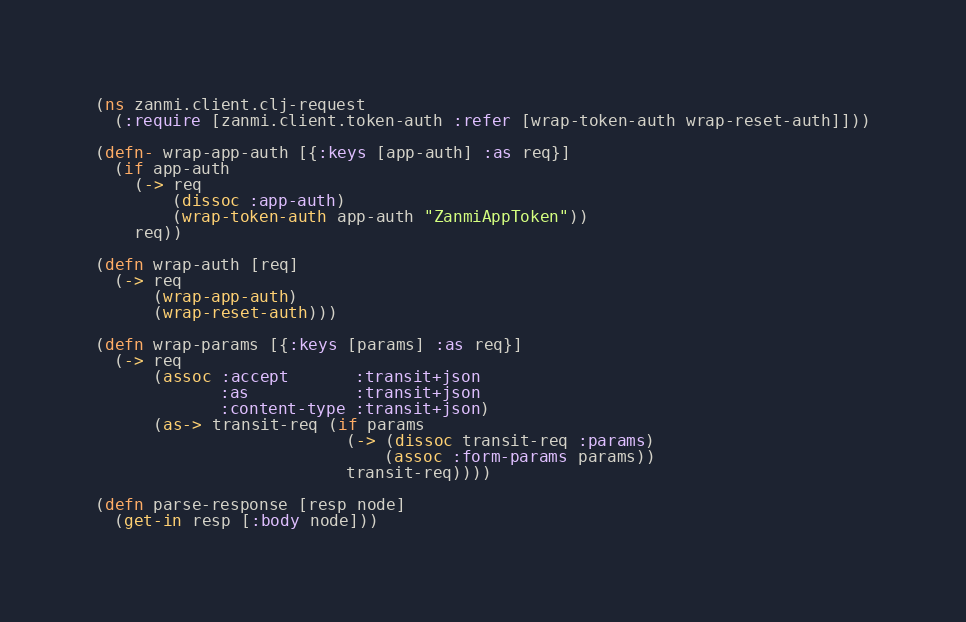Convert code to text. <code><loc_0><loc_0><loc_500><loc_500><_Clojure_>(ns zanmi.client.clj-request
  (:require [zanmi.client.token-auth :refer [wrap-token-auth wrap-reset-auth]]))

(defn- wrap-app-auth [{:keys [app-auth] :as req}]
  (if app-auth
    (-> req
        (dissoc :app-auth)
        (wrap-token-auth app-auth "ZanmiAppToken"))
    req))

(defn wrap-auth [req]
  (-> req
      (wrap-app-auth)
      (wrap-reset-auth)))

(defn wrap-params [{:keys [params] :as req}]
  (-> req
      (assoc :accept       :transit+json
             :as           :transit+json
             :content-type :transit+json)
      (as-> transit-req (if params
                          (-> (dissoc transit-req :params)
                              (assoc :form-params params))
                          transit-req))))

(defn parse-response [resp node]
  (get-in resp [:body node]))
</code> 